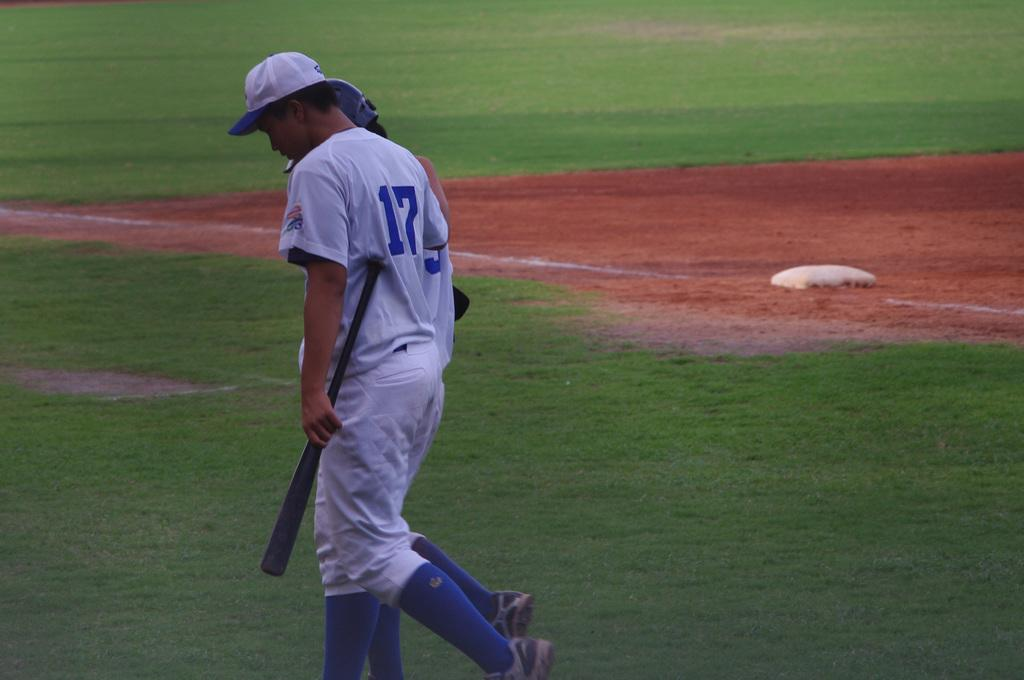<image>
Present a compact description of the photo's key features. a baseball player with the number 17 on the back of his jersey 